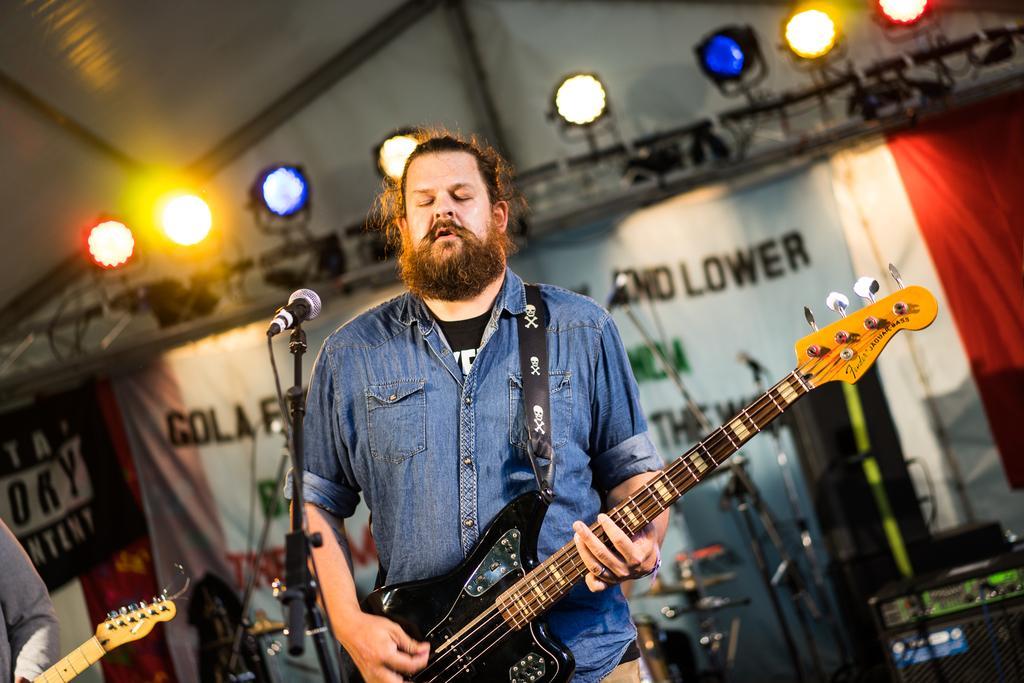In one or two sentences, can you explain what this image depicts? On the background we can see lights, banners. Here we can see one man wearing denim jacket, standing in front of a mike and playing guitar. On the background we can see drums , electronic device. Here we can see partial part of a guitar and a person. 